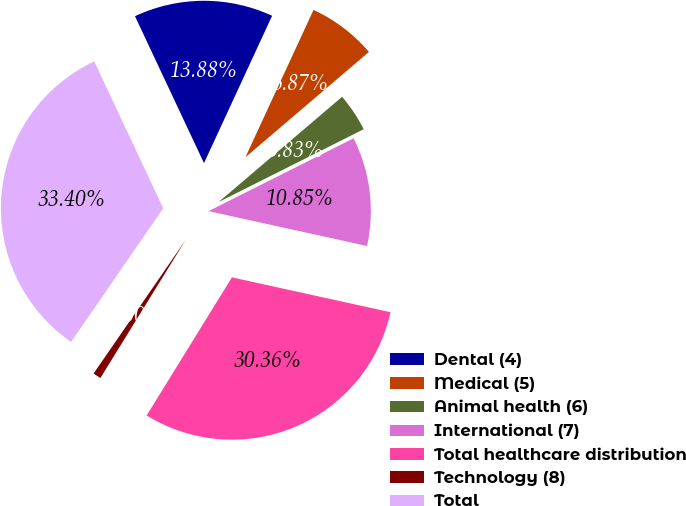Convert chart. <chart><loc_0><loc_0><loc_500><loc_500><pie_chart><fcel>Dental (4)<fcel>Medical (5)<fcel>Animal health (6)<fcel>International (7)<fcel>Total healthcare distribution<fcel>Technology (8)<fcel>Total<nl><fcel>13.88%<fcel>6.87%<fcel>3.83%<fcel>10.85%<fcel>30.36%<fcel>0.8%<fcel>33.4%<nl></chart> 